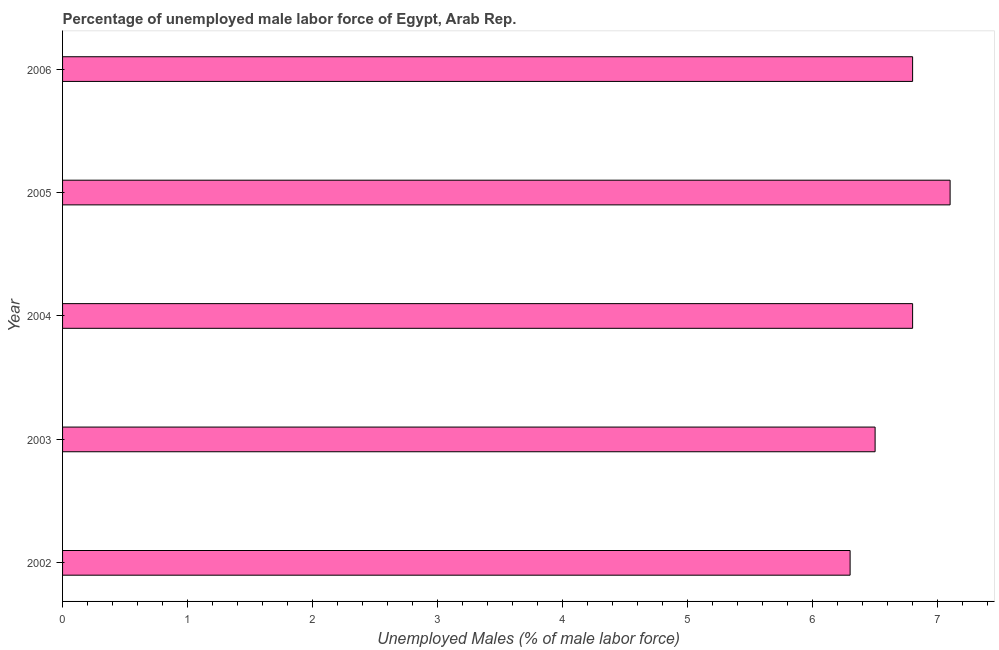What is the title of the graph?
Your response must be concise. Percentage of unemployed male labor force of Egypt, Arab Rep. What is the label or title of the X-axis?
Give a very brief answer. Unemployed Males (% of male labor force). What is the label or title of the Y-axis?
Your response must be concise. Year. What is the total unemployed male labour force in 2004?
Provide a succinct answer. 6.8. Across all years, what is the maximum total unemployed male labour force?
Keep it short and to the point. 7.1. Across all years, what is the minimum total unemployed male labour force?
Provide a succinct answer. 6.3. In which year was the total unemployed male labour force minimum?
Provide a succinct answer. 2002. What is the sum of the total unemployed male labour force?
Give a very brief answer. 33.5. What is the median total unemployed male labour force?
Provide a short and direct response. 6.8. In how many years, is the total unemployed male labour force greater than 5.2 %?
Your answer should be very brief. 5. Is the difference between the total unemployed male labour force in 2002 and 2006 greater than the difference between any two years?
Your answer should be compact. No. What is the difference between the highest and the second highest total unemployed male labour force?
Offer a terse response. 0.3. What is the difference between the highest and the lowest total unemployed male labour force?
Ensure brevity in your answer.  0.8. How many bars are there?
Your answer should be very brief. 5. What is the Unemployed Males (% of male labor force) of 2002?
Your response must be concise. 6.3. What is the Unemployed Males (% of male labor force) in 2003?
Give a very brief answer. 6.5. What is the Unemployed Males (% of male labor force) of 2004?
Give a very brief answer. 6.8. What is the Unemployed Males (% of male labor force) of 2005?
Your response must be concise. 7.1. What is the Unemployed Males (% of male labor force) of 2006?
Provide a succinct answer. 6.8. What is the difference between the Unemployed Males (% of male labor force) in 2002 and 2005?
Provide a succinct answer. -0.8. What is the difference between the Unemployed Males (% of male labor force) in 2002 and 2006?
Provide a succinct answer. -0.5. What is the difference between the Unemployed Males (% of male labor force) in 2003 and 2004?
Your response must be concise. -0.3. What is the difference between the Unemployed Males (% of male labor force) in 2003 and 2006?
Keep it short and to the point. -0.3. What is the difference between the Unemployed Males (% of male labor force) in 2004 and 2006?
Keep it short and to the point. 0. What is the difference between the Unemployed Males (% of male labor force) in 2005 and 2006?
Your answer should be very brief. 0.3. What is the ratio of the Unemployed Males (% of male labor force) in 2002 to that in 2004?
Ensure brevity in your answer.  0.93. What is the ratio of the Unemployed Males (% of male labor force) in 2002 to that in 2005?
Provide a short and direct response. 0.89. What is the ratio of the Unemployed Males (% of male labor force) in 2002 to that in 2006?
Keep it short and to the point. 0.93. What is the ratio of the Unemployed Males (% of male labor force) in 2003 to that in 2004?
Ensure brevity in your answer.  0.96. What is the ratio of the Unemployed Males (% of male labor force) in 2003 to that in 2005?
Make the answer very short. 0.92. What is the ratio of the Unemployed Males (% of male labor force) in 2003 to that in 2006?
Your answer should be very brief. 0.96. What is the ratio of the Unemployed Males (% of male labor force) in 2004 to that in 2005?
Ensure brevity in your answer.  0.96. What is the ratio of the Unemployed Males (% of male labor force) in 2004 to that in 2006?
Give a very brief answer. 1. What is the ratio of the Unemployed Males (% of male labor force) in 2005 to that in 2006?
Make the answer very short. 1.04. 